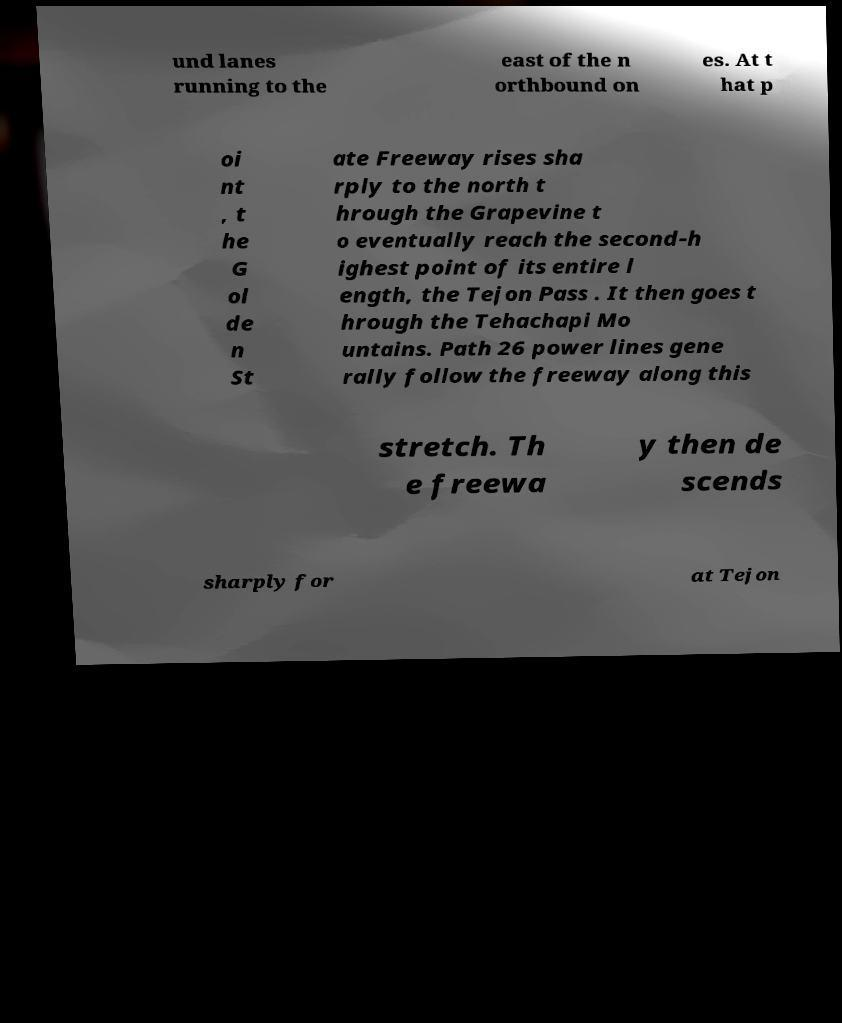Could you extract and type out the text from this image? und lanes running to the east of the n orthbound on es. At t hat p oi nt , t he G ol de n St ate Freeway rises sha rply to the north t hrough the Grapevine t o eventually reach the second-h ighest point of its entire l ength, the Tejon Pass . It then goes t hrough the Tehachapi Mo untains. Path 26 power lines gene rally follow the freeway along this stretch. Th e freewa y then de scends sharply for at Tejon 